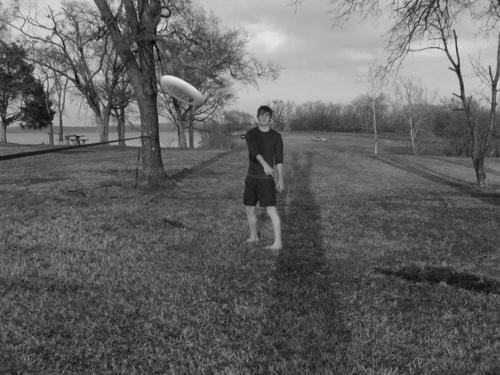What sport is being shown?
Be succinct. Frisbee. Is it sunny?
Short answer required. No. How many kites are in the image?
Quick response, please. 0. What color is the photo?
Short answer required. Black and white. Is there a big building in the background?
Keep it brief. No. Why is the boy barefoot?
Answer briefly. Yes. Is this an urban location?
Concise answer only. No. How many children are at the playground?
Short answer required. 1. Why do you think this child is probably not wearing a helmet?
Be succinct. Frisbee. Is this an adult?
Quick response, please. Yes. What is the boy doing?
Concise answer only. Throwing frisbee. 